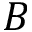<formula> <loc_0><loc_0><loc_500><loc_500>B</formula> 